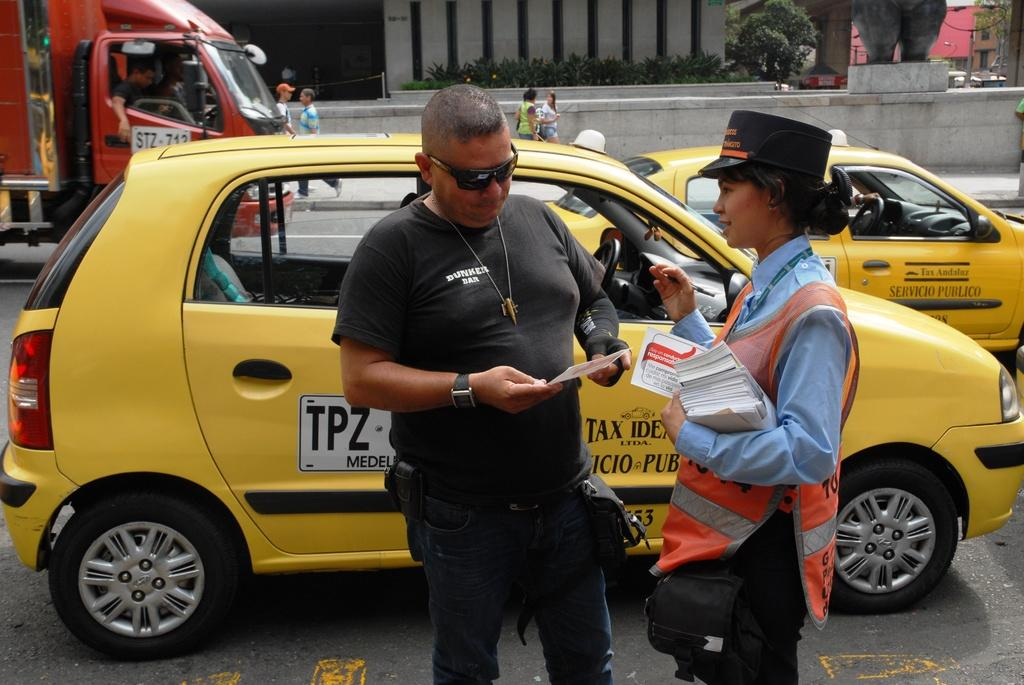<image>
Share a concise interpretation of the image provided. A TPZ medallion is displayed on the side of a yellow taxi. 